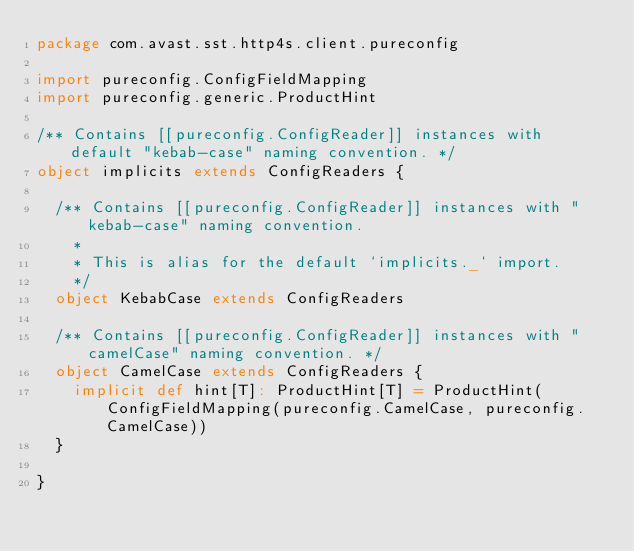<code> <loc_0><loc_0><loc_500><loc_500><_Scala_>package com.avast.sst.http4s.client.pureconfig

import pureconfig.ConfigFieldMapping
import pureconfig.generic.ProductHint

/** Contains [[pureconfig.ConfigReader]] instances with default "kebab-case" naming convention. */
object implicits extends ConfigReaders {

  /** Contains [[pureconfig.ConfigReader]] instances with "kebab-case" naming convention.
    *
    * This is alias for the default `implicits._` import.
    */
  object KebabCase extends ConfigReaders

  /** Contains [[pureconfig.ConfigReader]] instances with "camelCase" naming convention. */
  object CamelCase extends ConfigReaders {
    implicit def hint[T]: ProductHint[T] = ProductHint(ConfigFieldMapping(pureconfig.CamelCase, pureconfig.CamelCase))
  }

}
</code> 